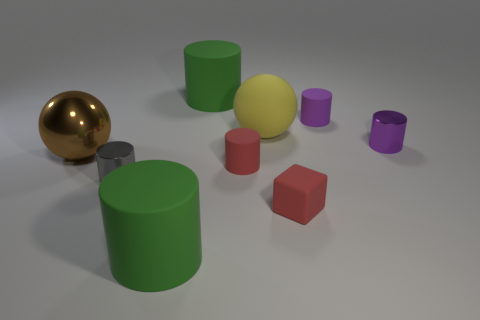There is a small rubber cylinder that is left of the large rubber sphere; is its color the same as the rubber block?
Provide a short and direct response. Yes. There is a tiny block; is its color the same as the tiny matte cylinder that is in front of the purple metal cylinder?
Keep it short and to the point. Yes. Are there any purple shiny cylinders that have the same size as the red matte block?
Your response must be concise. Yes. What is the material of the big cylinder that is in front of the big green rubber cylinder that is behind the small red block?
Offer a very short reply. Rubber. How many small matte things are the same color as the tiny cube?
Provide a succinct answer. 1. What is the shape of the small purple object that is the same material as the yellow thing?
Make the answer very short. Cylinder. What is the size of the metal cylinder that is left of the red matte cylinder?
Your answer should be compact. Small. Are there the same number of matte spheres that are in front of the large brown metal object and yellow balls in front of the yellow rubber sphere?
Keep it short and to the point. Yes. There is a shiny object that is to the right of the big green cylinder behind the red matte object in front of the gray cylinder; what color is it?
Keep it short and to the point. Purple. What number of objects are left of the red matte block and in front of the small purple matte cylinder?
Make the answer very short. 5. 